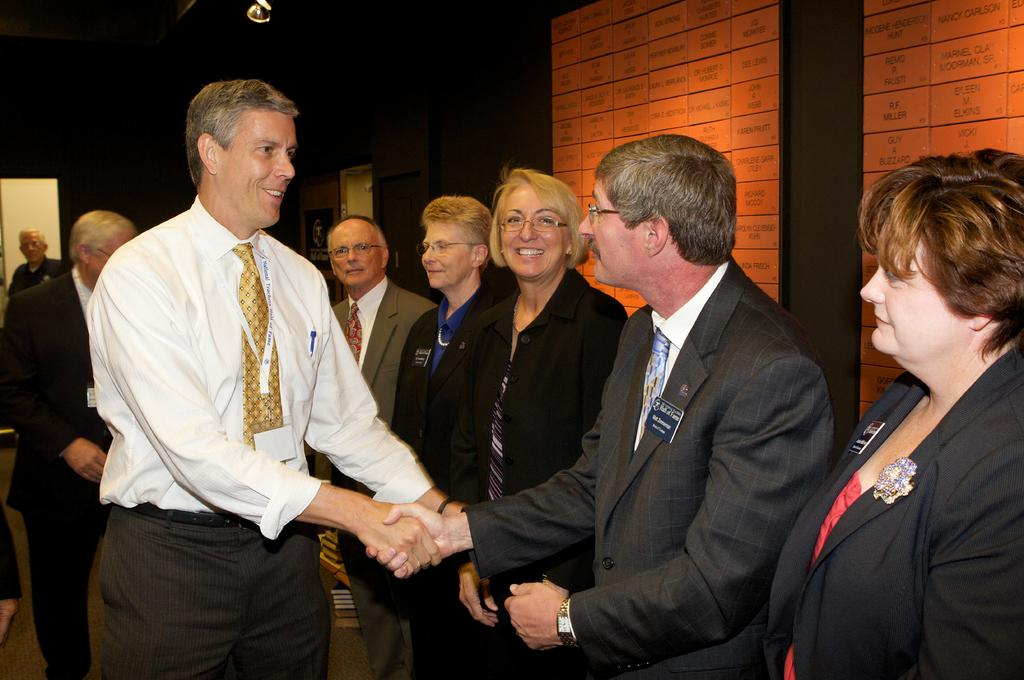What is happening between the people in the image? Two people are shaking hands in the image. How many people are present in the image? There are people standing in the image. What can be seen in the background of the image? There is a wall visible in the background of the image. What type of sponge is being used to clean the skin in the image? There is no sponge or skin visible in the image; it features people shaking hands with a wall in the background. 